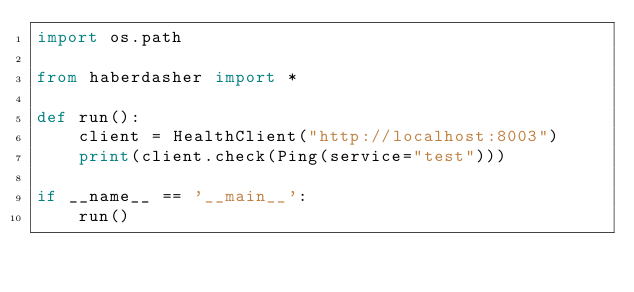<code> <loc_0><loc_0><loc_500><loc_500><_Python_>import os.path

from haberdasher import *

def run():
    client = HealthClient("http://localhost:8003")
    print(client.check(Ping(service="test")))

if __name__ == '__main__':
    run()
</code> 